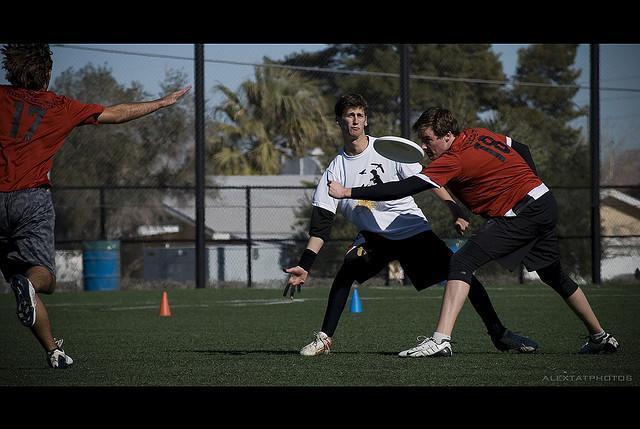How many orange cones do you see?
Give a very brief answer. 1. How many people are visible?
Give a very brief answer. 3. 